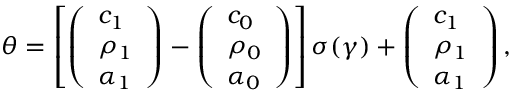<formula> <loc_0><loc_0><loc_500><loc_500>\theta = \left [ \left ( \begin{array} { l } { c _ { 1 } } \\ { \rho _ { 1 } } \\ { \alpha _ { 1 } } \end{array} \right ) - \left ( \begin{array} { l } { c _ { 0 } } \\ { \rho _ { 0 } } \\ { \alpha _ { 0 } } \end{array} \right ) \right ] \sigma ( \gamma ) + \left ( \begin{array} { l } { c _ { 1 } } \\ { \rho _ { 1 } } \\ { \alpha _ { 1 } } \end{array} \right ) ,</formula> 